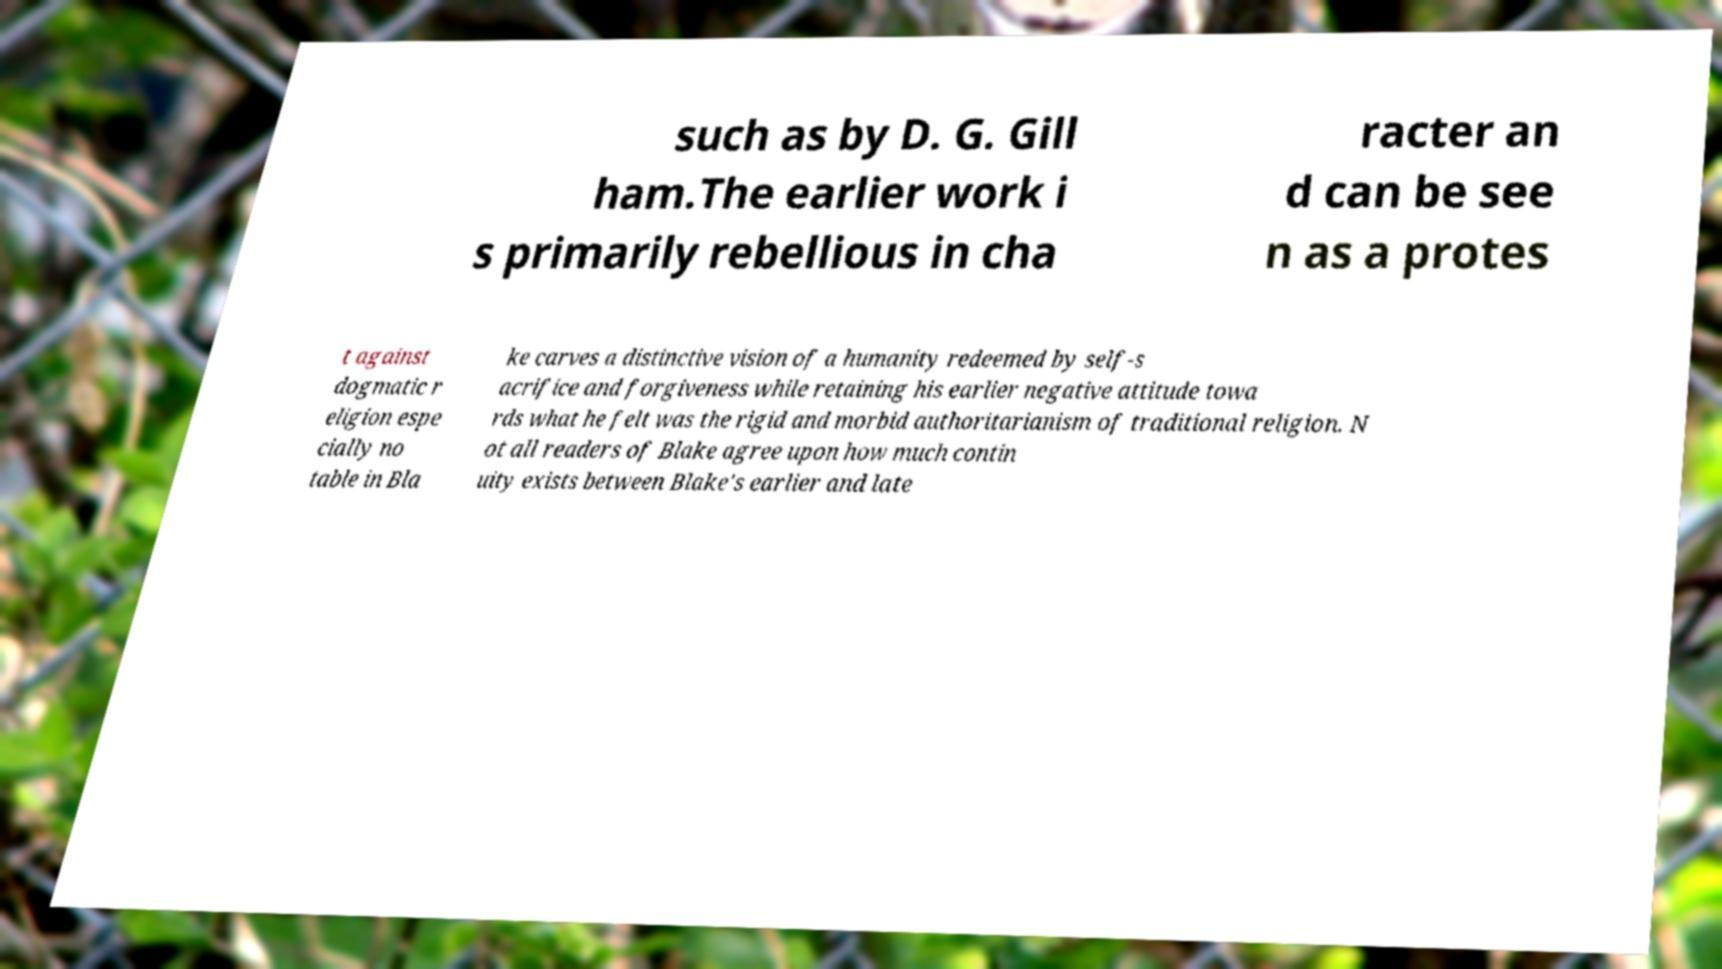Can you read and provide the text displayed in the image?This photo seems to have some interesting text. Can you extract and type it out for me? such as by D. G. Gill ham.The earlier work i s primarily rebellious in cha racter an d can be see n as a protes t against dogmatic r eligion espe cially no table in Bla ke carves a distinctive vision of a humanity redeemed by self-s acrifice and forgiveness while retaining his earlier negative attitude towa rds what he felt was the rigid and morbid authoritarianism of traditional religion. N ot all readers of Blake agree upon how much contin uity exists between Blake's earlier and late 